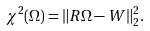<formula> <loc_0><loc_0><loc_500><loc_500>\chi ^ { 2 } ( \Omega ) = \| R \Omega - W \| _ { 2 } ^ { 2 } .</formula> 